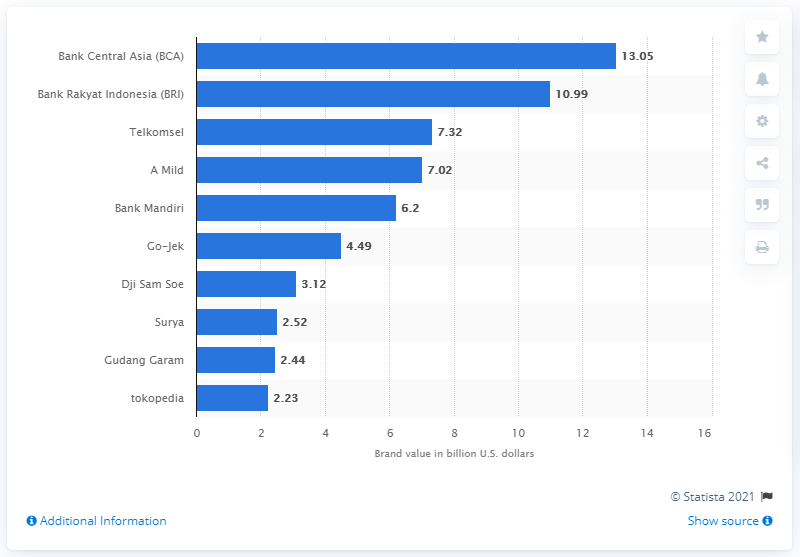What information can you provide about the least valued brand on the chart? The least valued brand on the chart is Tokopedia, with a brand value of 2.23 billion U.S. dollars. Tokopedia is an Indonesian technology company specializing in e-commerce, and this figure highlights its emerging presence in the market. 